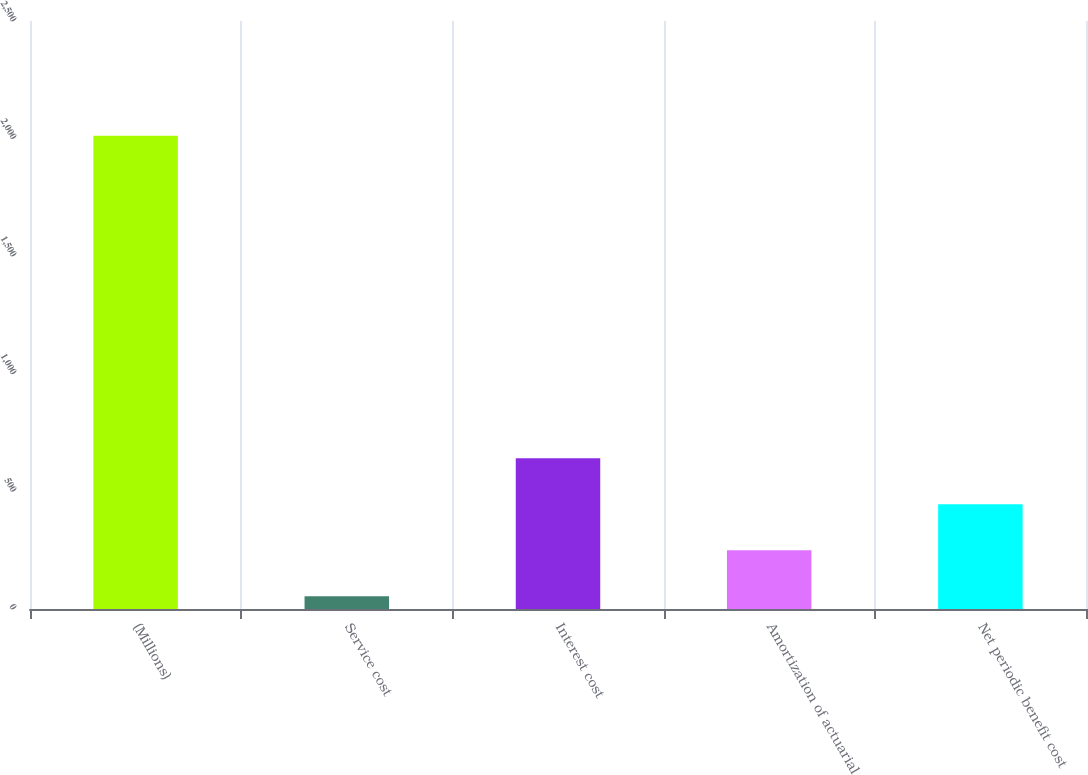<chart> <loc_0><loc_0><loc_500><loc_500><bar_chart><fcel>(Millions)<fcel>Service cost<fcel>Interest cost<fcel>Amortization of actuarial<fcel>Net periodic benefit cost<nl><fcel>2012<fcel>54<fcel>641.4<fcel>249.8<fcel>445.6<nl></chart> 